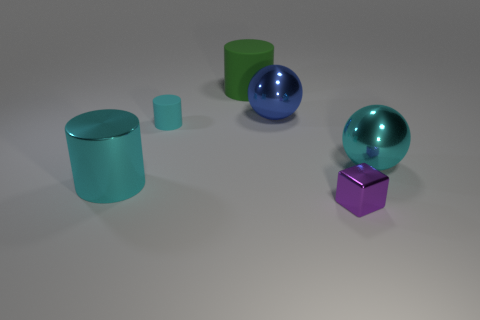Subtract all tiny matte cylinders. How many cylinders are left? 2 Subtract 1 cylinders. How many cylinders are left? 2 Add 4 purple shiny blocks. How many objects exist? 10 Subtract all green cylinders. How many cylinders are left? 2 Subtract all cubes. How many objects are left? 5 Add 3 gray matte cubes. How many gray matte cubes exist? 3 Subtract 0 red blocks. How many objects are left? 6 Subtract all red cylinders. Subtract all blue balls. How many cylinders are left? 3 Subtract all brown cubes. How many cyan cylinders are left? 2 Subtract all large cyan shiny spheres. Subtract all small metallic blocks. How many objects are left? 4 